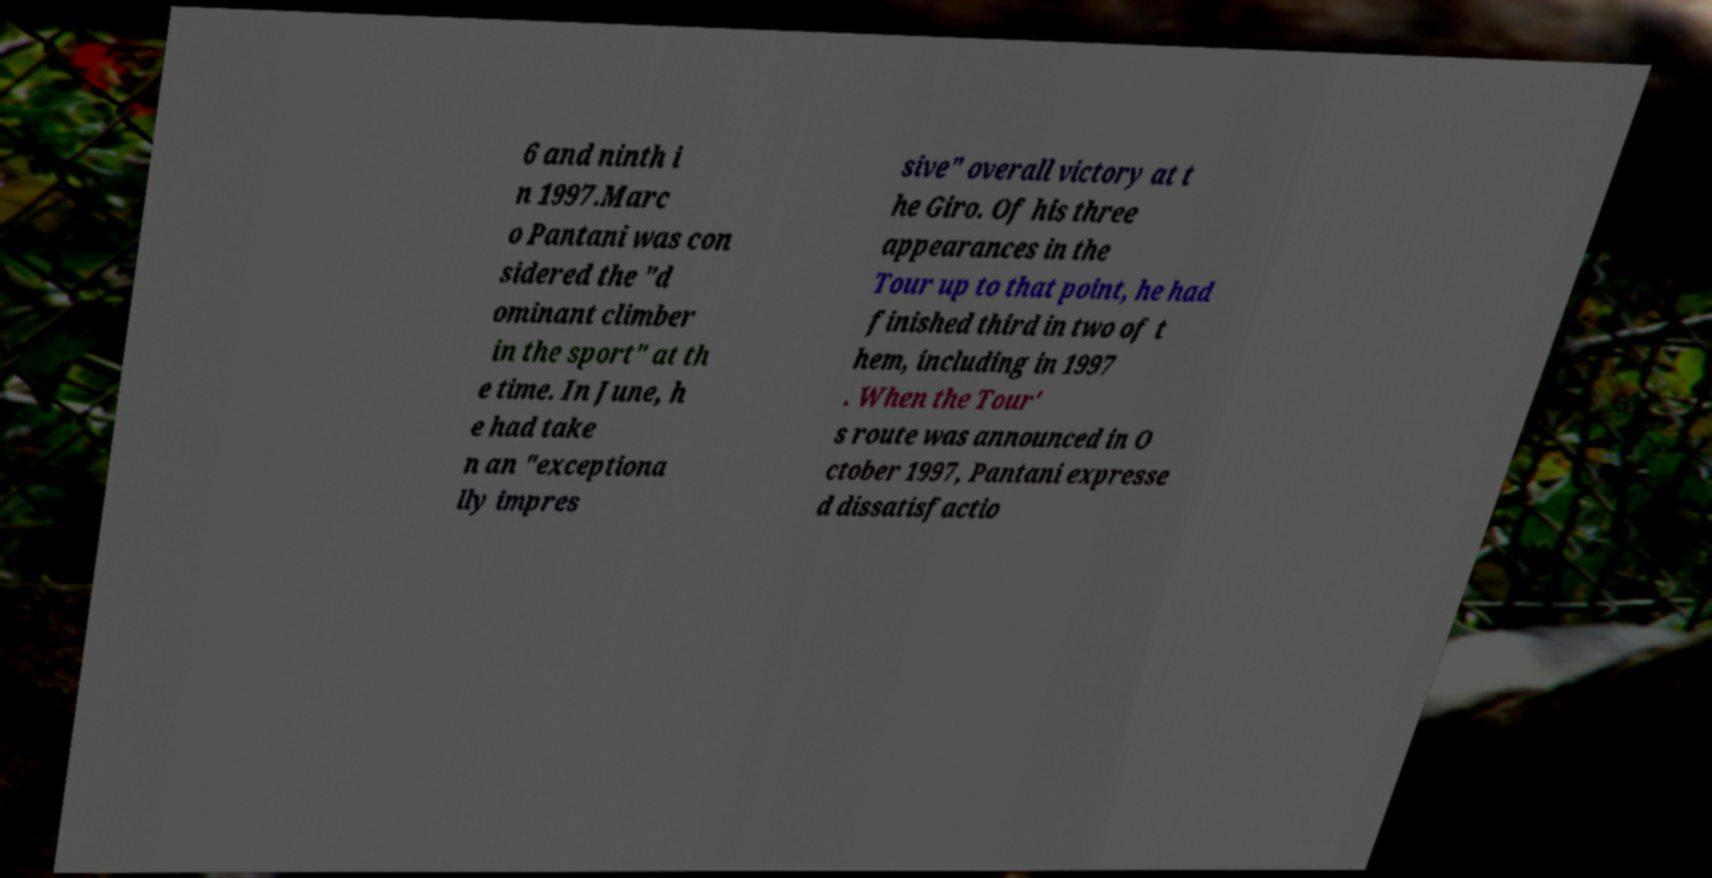I need the written content from this picture converted into text. Can you do that? 6 and ninth i n 1997.Marc o Pantani was con sidered the "d ominant climber in the sport" at th e time. In June, h e had take n an "exceptiona lly impres sive" overall victory at t he Giro. Of his three appearances in the Tour up to that point, he had finished third in two of t hem, including in 1997 . When the Tour' s route was announced in O ctober 1997, Pantani expresse d dissatisfactio 